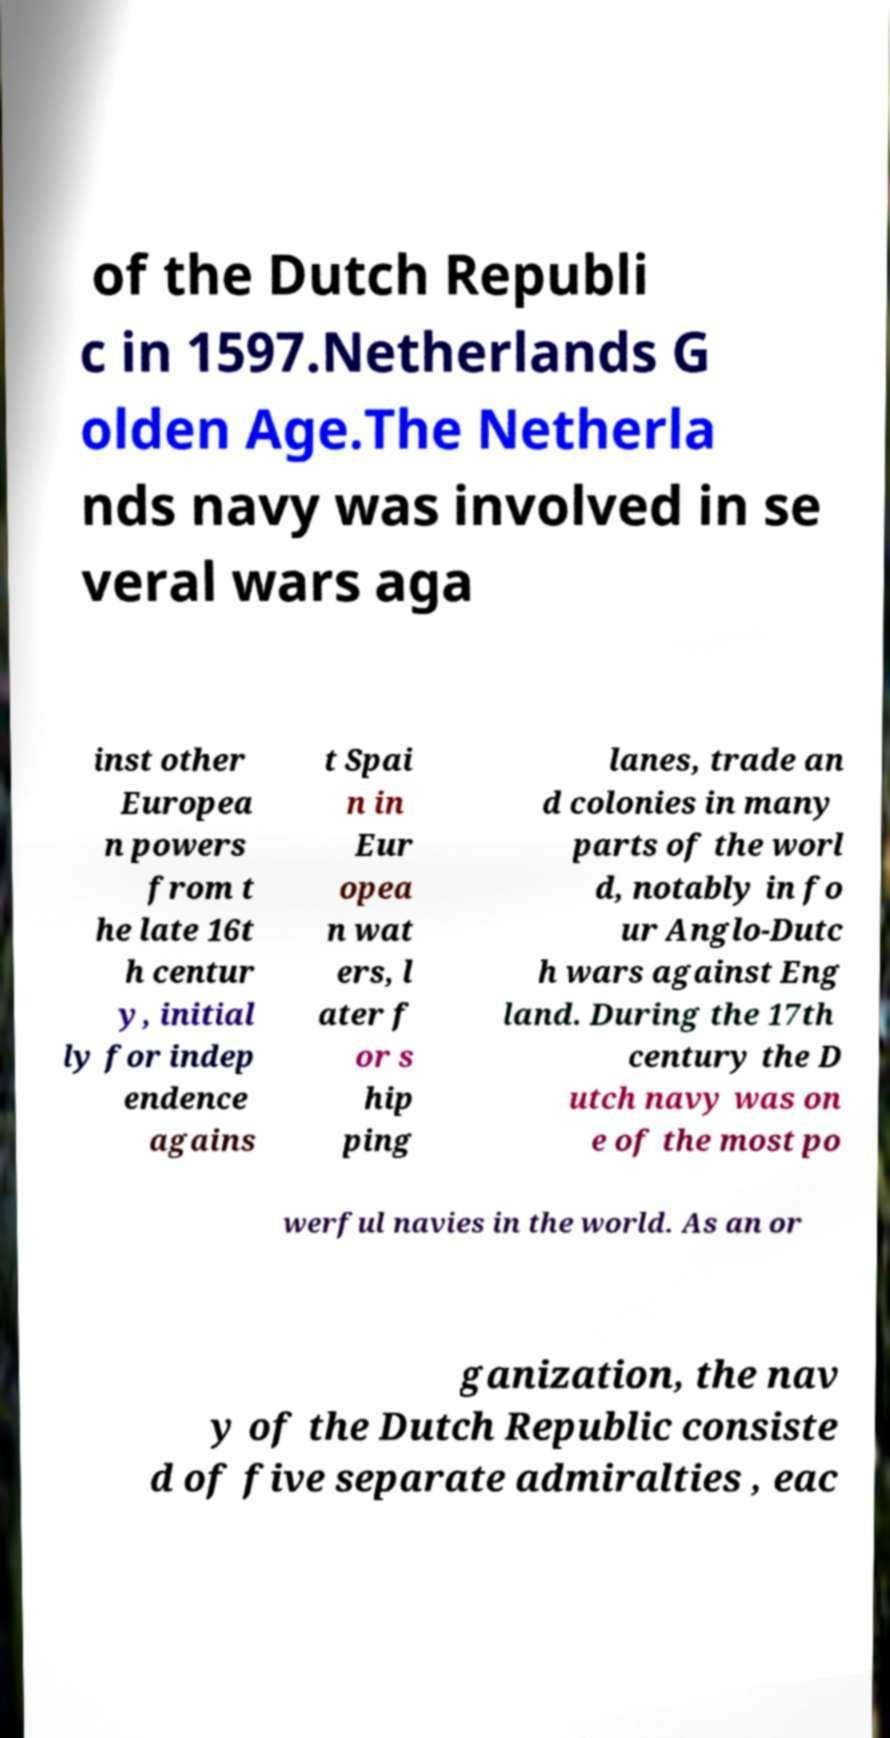For documentation purposes, I need the text within this image transcribed. Could you provide that? of the Dutch Republi c in 1597.Netherlands G olden Age.The Netherla nds navy was involved in se veral wars aga inst other Europea n powers from t he late 16t h centur y, initial ly for indep endence agains t Spai n in Eur opea n wat ers, l ater f or s hip ping lanes, trade an d colonies in many parts of the worl d, notably in fo ur Anglo-Dutc h wars against Eng land. During the 17th century the D utch navy was on e of the most po werful navies in the world. As an or ganization, the nav y of the Dutch Republic consiste d of five separate admiralties , eac 